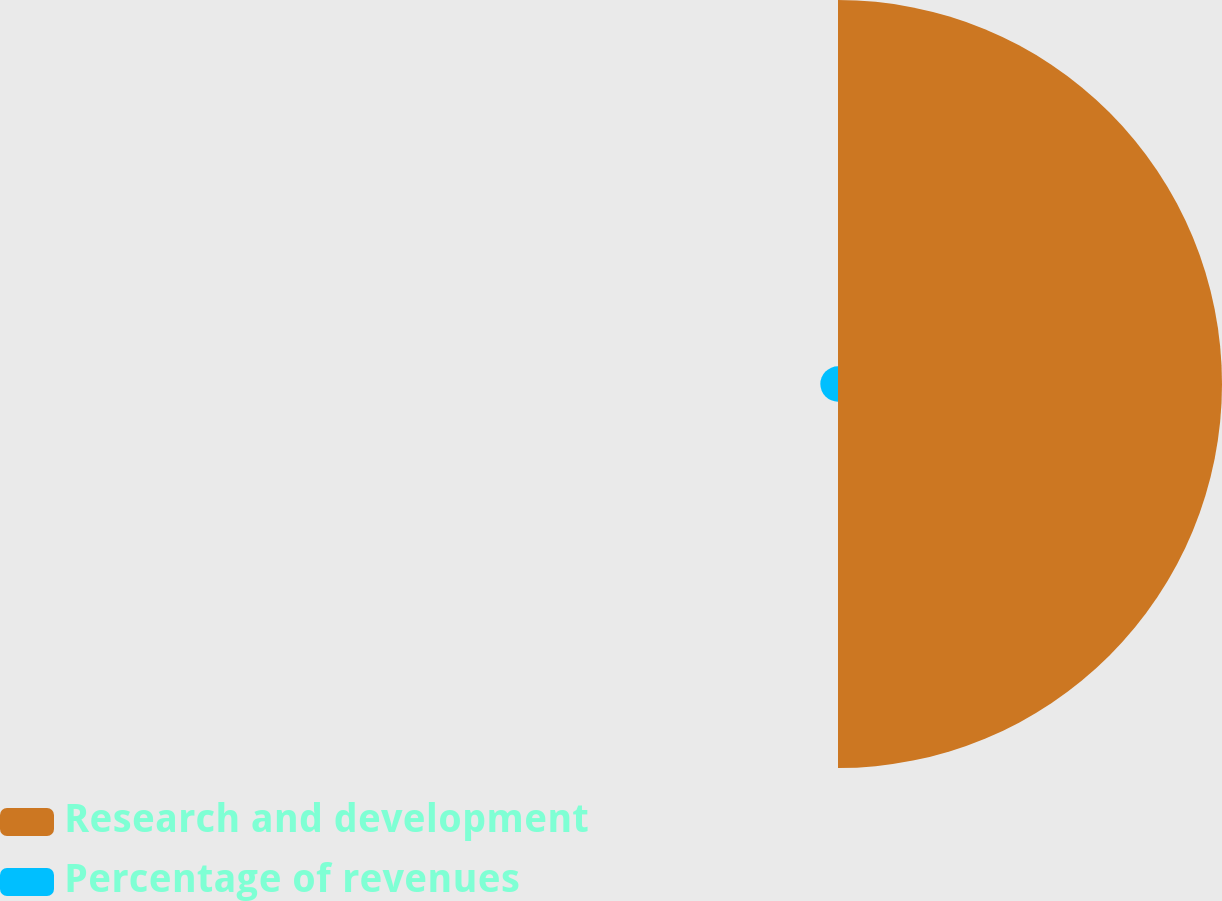<chart> <loc_0><loc_0><loc_500><loc_500><pie_chart><fcel>Research and development<fcel>Percentage of revenues<nl><fcel>95.6%<fcel>4.4%<nl></chart> 